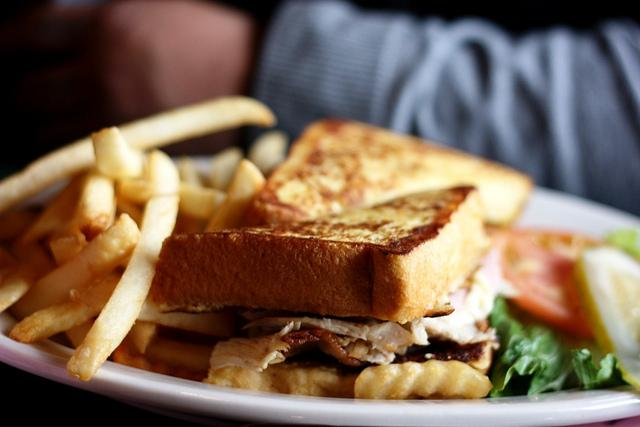What commonly goes on the long light yellow food here? ketchup 